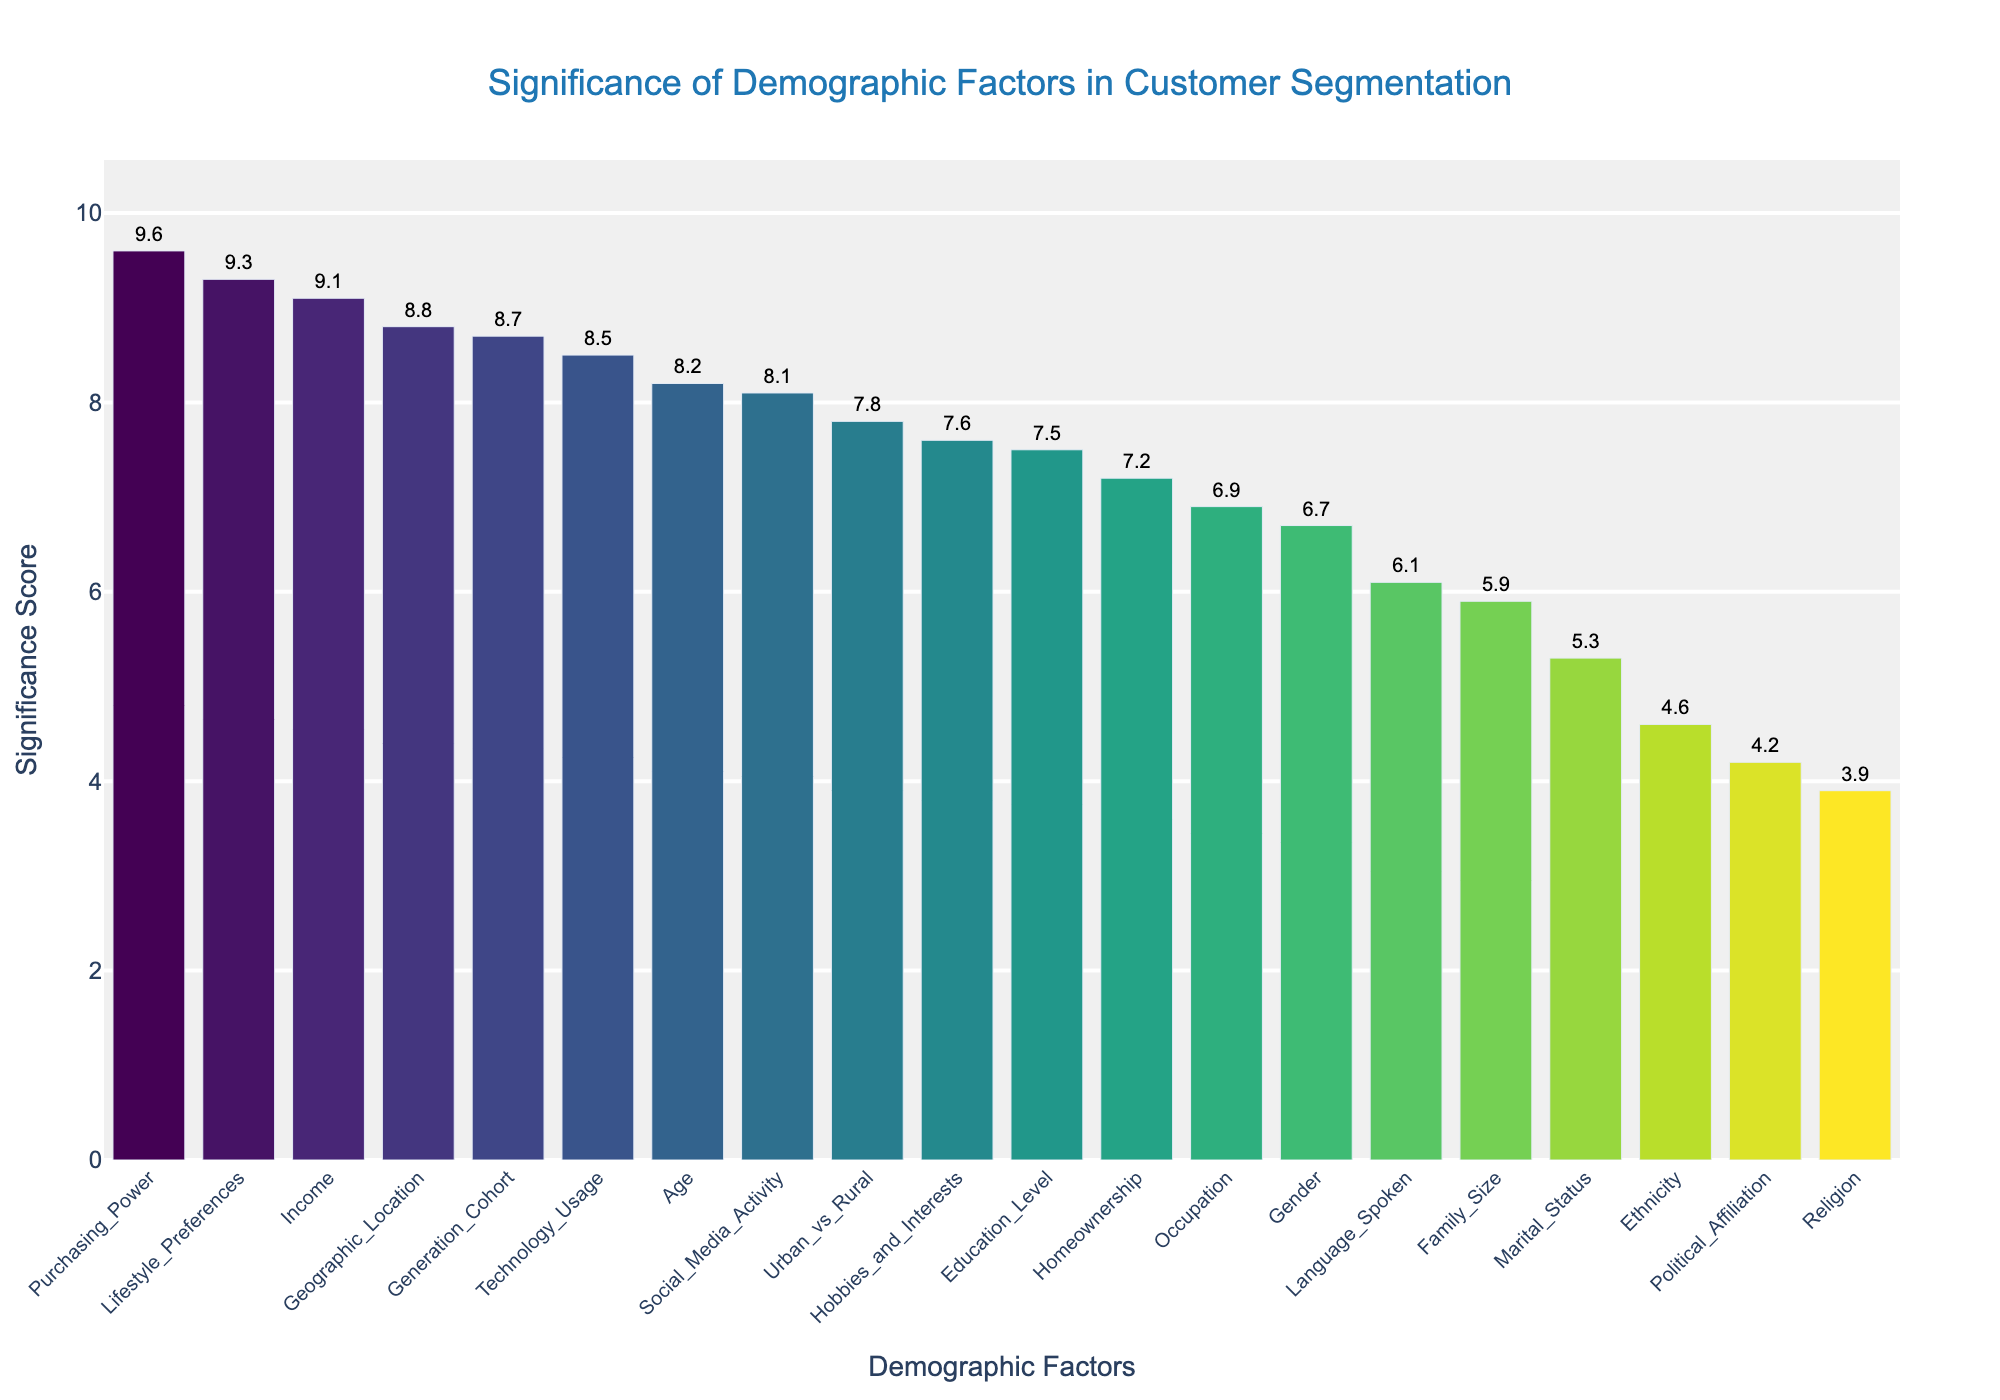What is the title of the figure? The title is located at the top of the figure and is usually more prominent than other text elements. The title helps the viewer understand the primary focus of the figure.
Answer: Significance of Demographic Factors in Customer Segmentation Which demographic factor has the highest significance score? The highest bar represents the demographic factor with the highest significance score. The text label at the top of this bar indicates its name.
Answer: Purchasing_Power How many demographic factors have a significance score greater than 8.0? To find this, count the number of bars whose heights exceed the 8.0 mark on the y-axis.
Answer: 8 What is the significance score for Geographic Location? Locate the bar labeled "Geographic Location" and read the numerical value from the text label above it.
Answer: 8.8 Which demographic factor has a lower significance score: Marital Status or Ethnicity? Compare the height of the bars labeled "Marital Status" and "Ethnicity", and identify which is lower.
Answer: Ethnicity What is the range of significance scores in the plot? The range is the difference between the maximum and minimum values of the significance score. Locate the highest and lowest bars and subtract the lower score from the higher.
Answer: 9.6 - 3.9 = 5.7 What is the average significance score of the factors "Age", "Gender", and "Income"? Sum the significance scores of "Age", "Gender", and "Income" and divide by 3.
Answer: (8.2 + 6.7 + 9.1) / 3 = 8.0 Which demographic factors have a significance score below 5.0? Identify and list the bars with heights that fall below the 5.0 mark on the y-axis.
Answer: Ethnicity, Religion, Political Affiliation What is the combined significance score of factors related to living environment (Urban vs Rural) and Geographic Location? Add the significance scores of "Urban vs Rural" and "Geographic Location".
Answer: 7.8 + 8.8 = 16.6 How do the significance scores for Technology Usage and Social Media Activity compare? Look at the bars for "Technology Usage" and "Social Media Activity" and compare their heights.
Answer: Technology Usage is slightly higher than Social Media Activity 